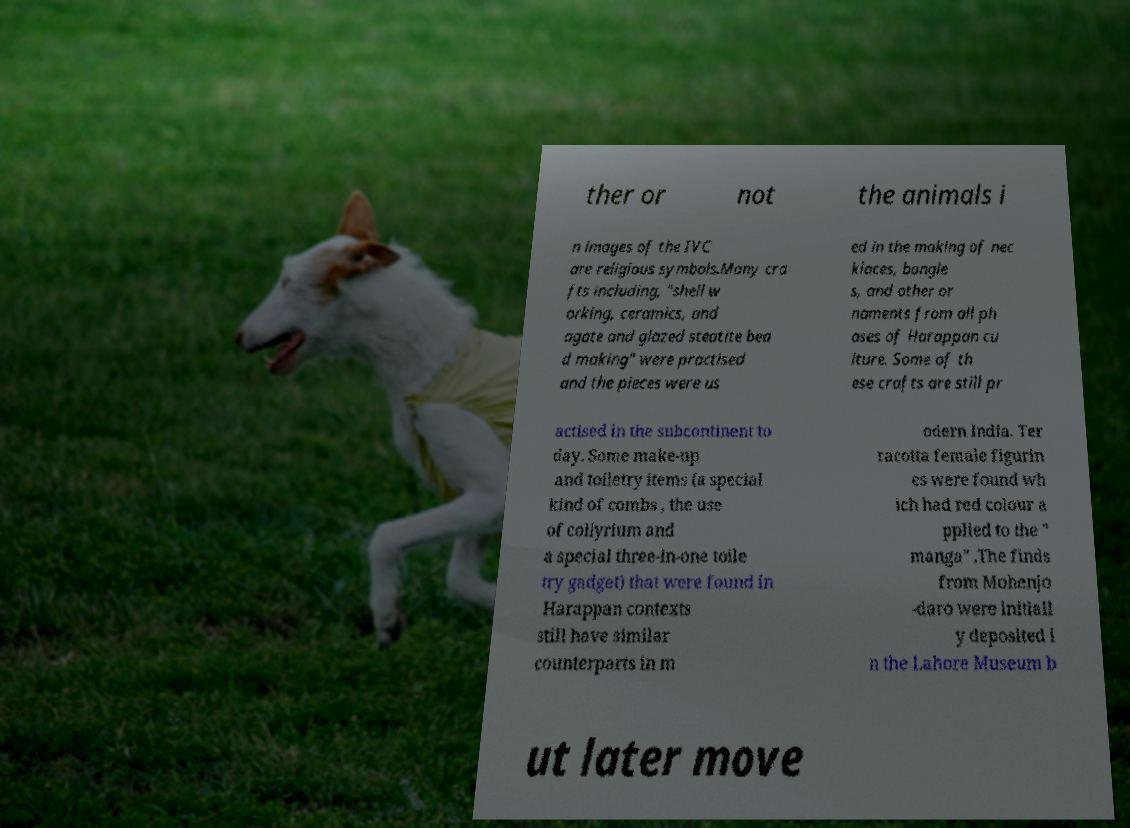For documentation purposes, I need the text within this image transcribed. Could you provide that? ther or not the animals i n images of the IVC are religious symbols.Many cra fts including, "shell w orking, ceramics, and agate and glazed steatite bea d making" were practised and the pieces were us ed in the making of nec klaces, bangle s, and other or naments from all ph ases of Harappan cu lture. Some of th ese crafts are still pr actised in the subcontinent to day. Some make-up and toiletry items (a special kind of combs , the use of collyrium and a special three-in-one toile try gadget) that were found in Harappan contexts still have similar counterparts in m odern India. Ter racotta female figurin es were found wh ich had red colour a pplied to the " manga" .The finds from Mohenjo -daro were initiall y deposited i n the Lahore Museum b ut later move 